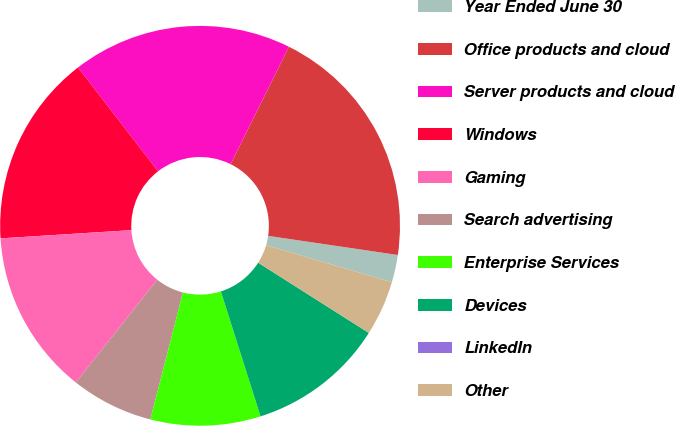Convert chart to OTSL. <chart><loc_0><loc_0><loc_500><loc_500><pie_chart><fcel>Year Ended June 30<fcel>Office products and cloud<fcel>Server products and cloud<fcel>Windows<fcel>Gaming<fcel>Search advertising<fcel>Enterprise Services<fcel>Devices<fcel>LinkedIn<fcel>Other<nl><fcel>2.22%<fcel>20.0%<fcel>17.78%<fcel>15.55%<fcel>13.33%<fcel>6.67%<fcel>8.89%<fcel>11.11%<fcel>0.0%<fcel>4.45%<nl></chart> 